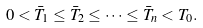<formula> <loc_0><loc_0><loc_500><loc_500>0 < \bar { T } _ { 1 } \leq \bar { T } _ { 2 } \leq \dots \leq \bar { T } _ { n } < T _ { 0 } .</formula> 